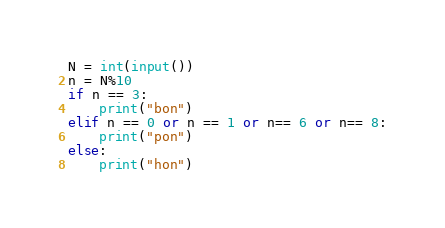<code> <loc_0><loc_0><loc_500><loc_500><_Python_>N = int(input())
n = N%10
if n == 3:
    print("bon")
elif n == 0 or n == 1 or n== 6 or n== 8:
    print("pon")
else:
    print("hon")</code> 